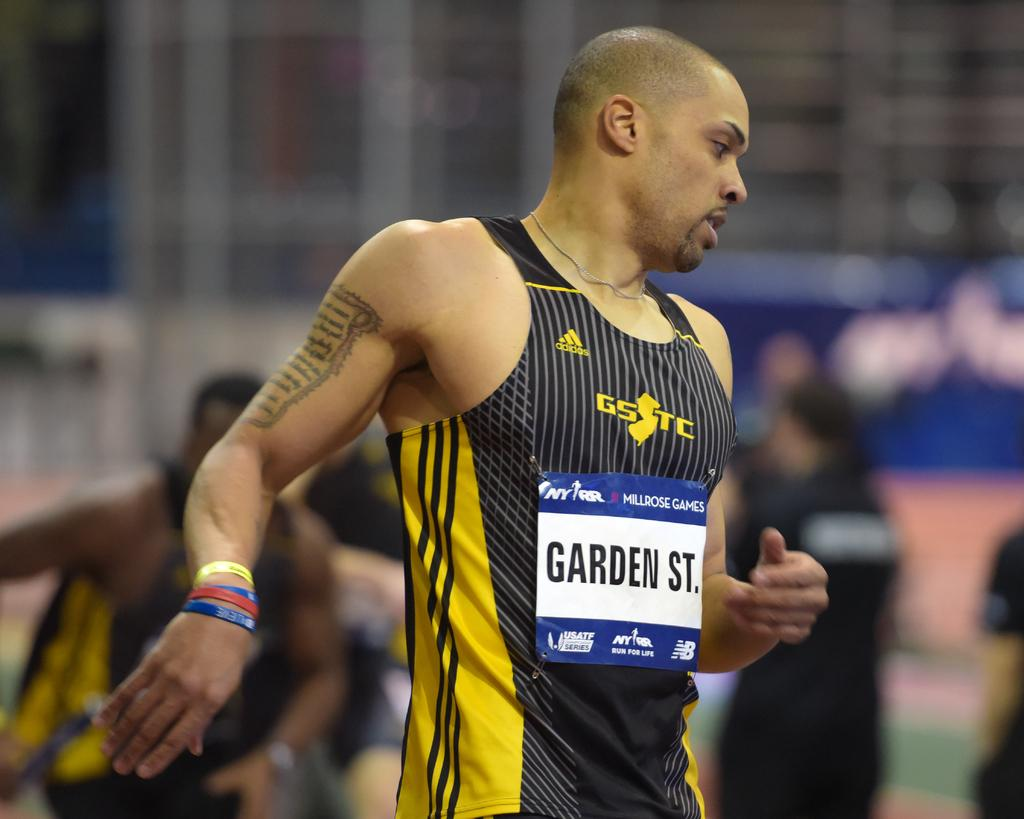<image>
Create a compact narrative representing the image presented. A man has a tank top on with an adidas logo on it. 